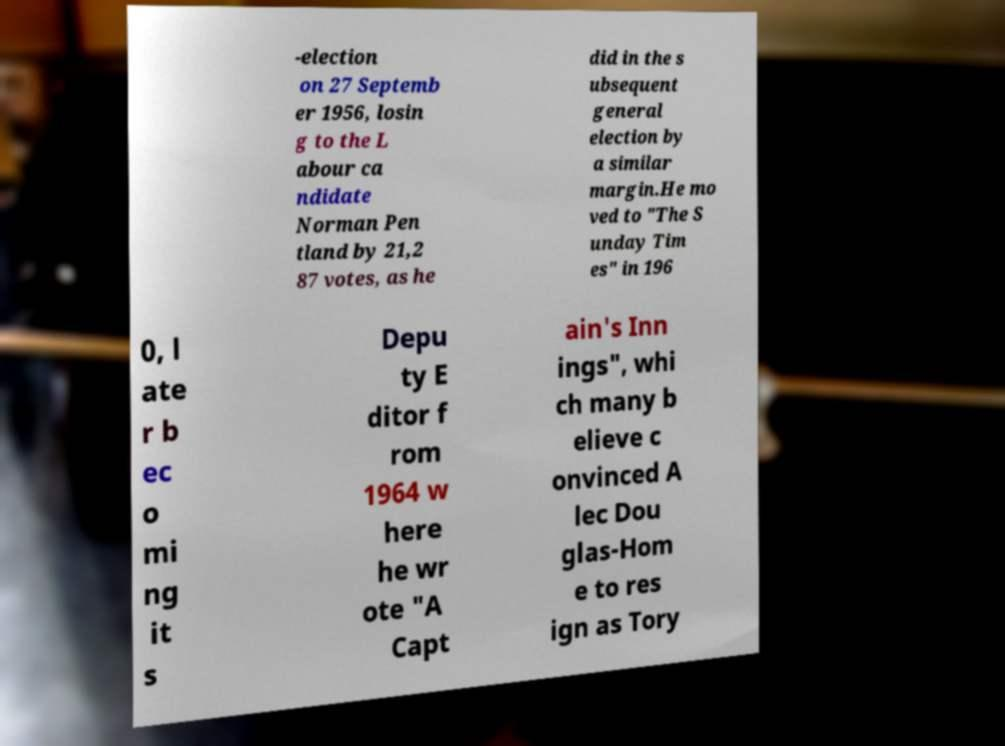What messages or text are displayed in this image? I need them in a readable, typed format. -election on 27 Septemb er 1956, losin g to the L abour ca ndidate Norman Pen tland by 21,2 87 votes, as he did in the s ubsequent general election by a similar margin.He mo ved to "The S unday Tim es" in 196 0, l ate r b ec o mi ng it s Depu ty E ditor f rom 1964 w here he wr ote "A Capt ain's Inn ings", whi ch many b elieve c onvinced A lec Dou glas-Hom e to res ign as Tory 